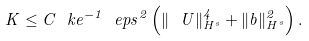Convert formula to latex. <formula><loc_0><loc_0><loc_500><loc_500>K \leq C \ k e ^ { - 1 } \ e p s ^ { 2 } \left ( \| \ U \| _ { H ^ { s } } ^ { 4 } + \| b \| _ { H ^ { s } } ^ { 2 } \right ) .</formula> 